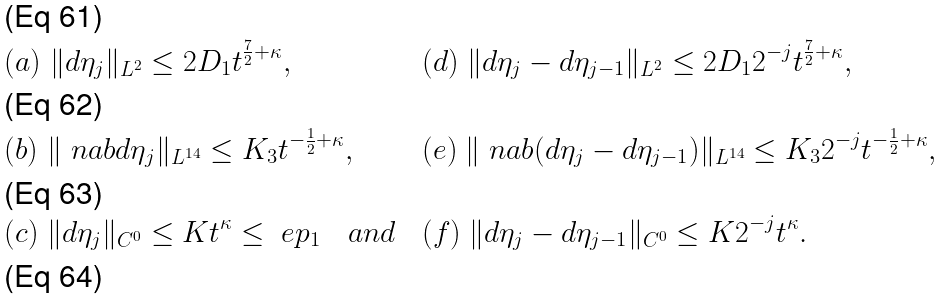Convert formula to latex. <formula><loc_0><loc_0><loc_500><loc_500>& ( a ) \ \| d \eta _ { j } \| _ { L ^ { 2 } } \leq 2 D _ { 1 } t ^ { \frac { 7 } { 2 } + \kappa } , & & ( d ) \ \| d \eta _ { j } - d \eta _ { j - 1 } \| _ { L ^ { 2 } } \leq 2 D _ { 1 } 2 ^ { - j } t ^ { \frac { 7 } { 2 } + \kappa } , \\ & ( b ) \ \| \ n a b d \eta _ { j } \| _ { L ^ { 1 4 } } \leq K _ { 3 } t ^ { - \frac { 1 } { 2 } + \kappa } , & & ( e ) \ \| \ n a b ( d \eta _ { j } - d \eta _ { j - 1 } ) \| _ { L ^ { 1 4 } } \leq K _ { 3 } 2 ^ { - j } t ^ { - \frac { 1 } { 2 } + \kappa } , \\ & ( c ) \ \| d \eta _ { j } \| _ { C ^ { 0 } } \leq K t ^ { \kappa } \leq \ e p _ { 1 } \quad a n d \ & & ( f ) \ \| d \eta _ { j } - d \eta _ { j - 1 } \| _ { C ^ { 0 } } \leq K 2 ^ { - j } t ^ { \kappa } . \\</formula> 